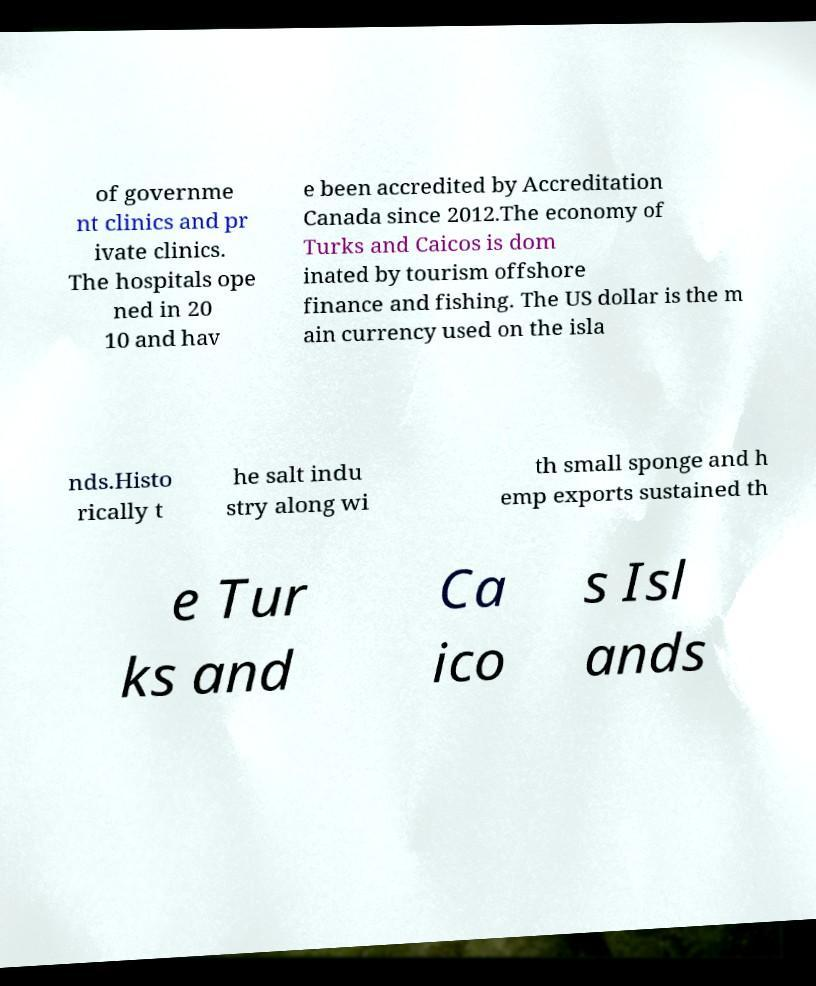Please read and relay the text visible in this image. What does it say? of governme nt clinics and pr ivate clinics. The hospitals ope ned in 20 10 and hav e been accredited by Accreditation Canada since 2012.The economy of Turks and Caicos is dom inated by tourism offshore finance and fishing. The US dollar is the m ain currency used on the isla nds.Histo rically t he salt indu stry along wi th small sponge and h emp exports sustained th e Tur ks and Ca ico s Isl ands 